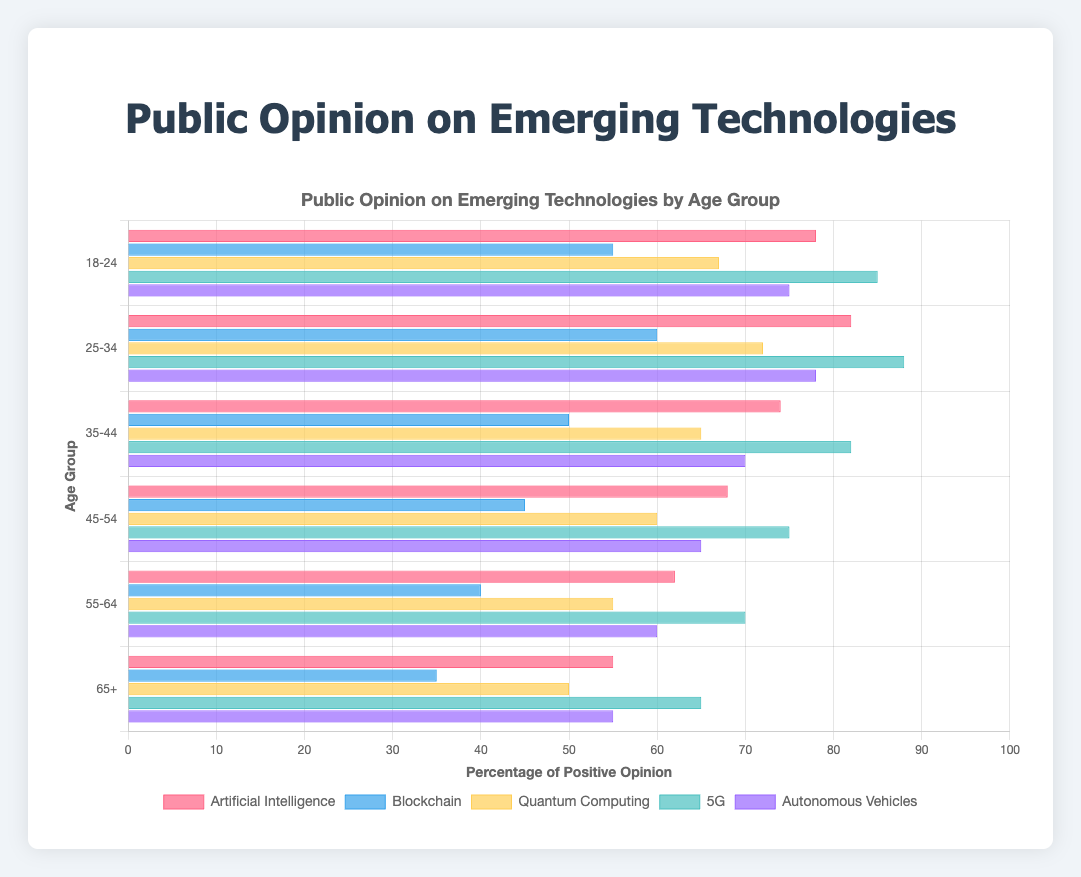What age group has the highest positive opinion on 5G technology? By examining the horizontal axis for the 5G bars across age groups, the bar corresponding to the 25-34 age group is the longest, indicating the highest percentage.
Answer: 25-34 Which technology has the least favorable opinion among the 55-64 age group? By looking at the bars for the 55-64 age group, the Blockchain bar is shortest, indicating the lowest percentage of positive opinion.
Answer: Blockchain What is the average positive opinion percentage on Artificial Intelligence across all age groups? Add the percentages of Artificial Intelligence across all age groups: (78 + 82 + 74 + 68 + 62 + 55) = 419. Since there are 6 age groups, divide by 6: 419 / 6 ≈ 69.83.
Answer: 69.83 Compare the positive opinion on Autonomous Vehicles between the 18-24 and 65+ age groups. Which group is more favorable and by how much? The 18-24 age group has a positive opinion of 75%, while the 65+ age group has 55%. The difference is 75 - 55 = 20%. Hence, the 18-24 group is more favorable by 20%.
Answer: 18-24, by 20% Which age group shows the least variation in their opinion percentages across the different technologies? Calculate the range for each age group (max percentage - min percentage). For the 25-34 group: 88 (max 5G) - 60 (min Blockchain) = 28. Evaluate similar calculations for all age groups and identify the smallest range. The least variation is in the 65+ group, with a range of 65 - 35 = 30, which is the smallest compared to other groups.
Answer: 65+ What is the cumulative positive opinion percentage for Quantum Computing for all age groups? Sum the percentages of Quantum Computing for all age groups: 67 + 72 + 65 + 60 + 55 + 50 = 369.
Answer: 369 Which technology tends to have a lower opinion across older age groups (45-54, 55-64, 65+)? By examining the bars for these age groups, Blockchain has the relatively shortest bars for 45-54, 55-64, and 65+ age groups.
Answer: Blockchain What is the percentage difference in opinion between Artificial Intelligence and Blockchain for the 35-44 age group? For 35-44, the opinion on Artificial Intelligence is 74% and Blockchain is 50%. The difference is 74 - 50 = 24%.
Answer: 24% In which age group is the opinion on Quantum Computing least favorable? By examining the bars for Quantum Computing across all age groups, the 65+ age group has the shortest bar at 50%.
Answer: 65+ What is the trend in positive opinion on Blockchain as age increases? Observing the datasets, the positive opinion on Blockchain decreases as the age group increases, e.g., 55% (18-24) to 35% (65+).
Answer: Decreasing 